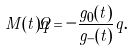Convert formula to latex. <formula><loc_0><loc_0><loc_500><loc_500>M ( t ) \dot { q } = - \frac { { g _ { 0 } ( t ) } } { g _ { - } ( t ) } q .</formula> 